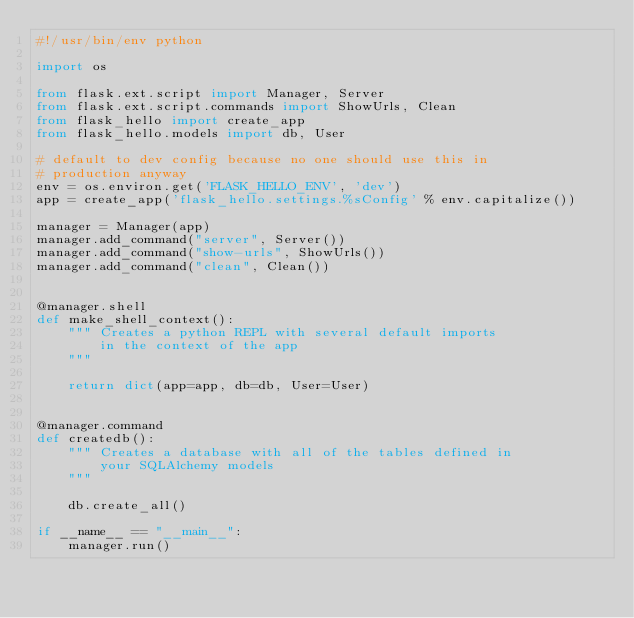Convert code to text. <code><loc_0><loc_0><loc_500><loc_500><_Python_>#!/usr/bin/env python

import os

from flask.ext.script import Manager, Server
from flask.ext.script.commands import ShowUrls, Clean
from flask_hello import create_app
from flask_hello.models import db, User

# default to dev config because no one should use this in
# production anyway
env = os.environ.get('FLASK_HELLO_ENV', 'dev')
app = create_app('flask_hello.settings.%sConfig' % env.capitalize())

manager = Manager(app)
manager.add_command("server", Server())
manager.add_command("show-urls", ShowUrls())
manager.add_command("clean", Clean())


@manager.shell
def make_shell_context():
    """ Creates a python REPL with several default imports
        in the context of the app
    """

    return dict(app=app, db=db, User=User)


@manager.command
def createdb():
    """ Creates a database with all of the tables defined in
        your SQLAlchemy models
    """

    db.create_all()

if __name__ == "__main__":
    manager.run()
</code> 